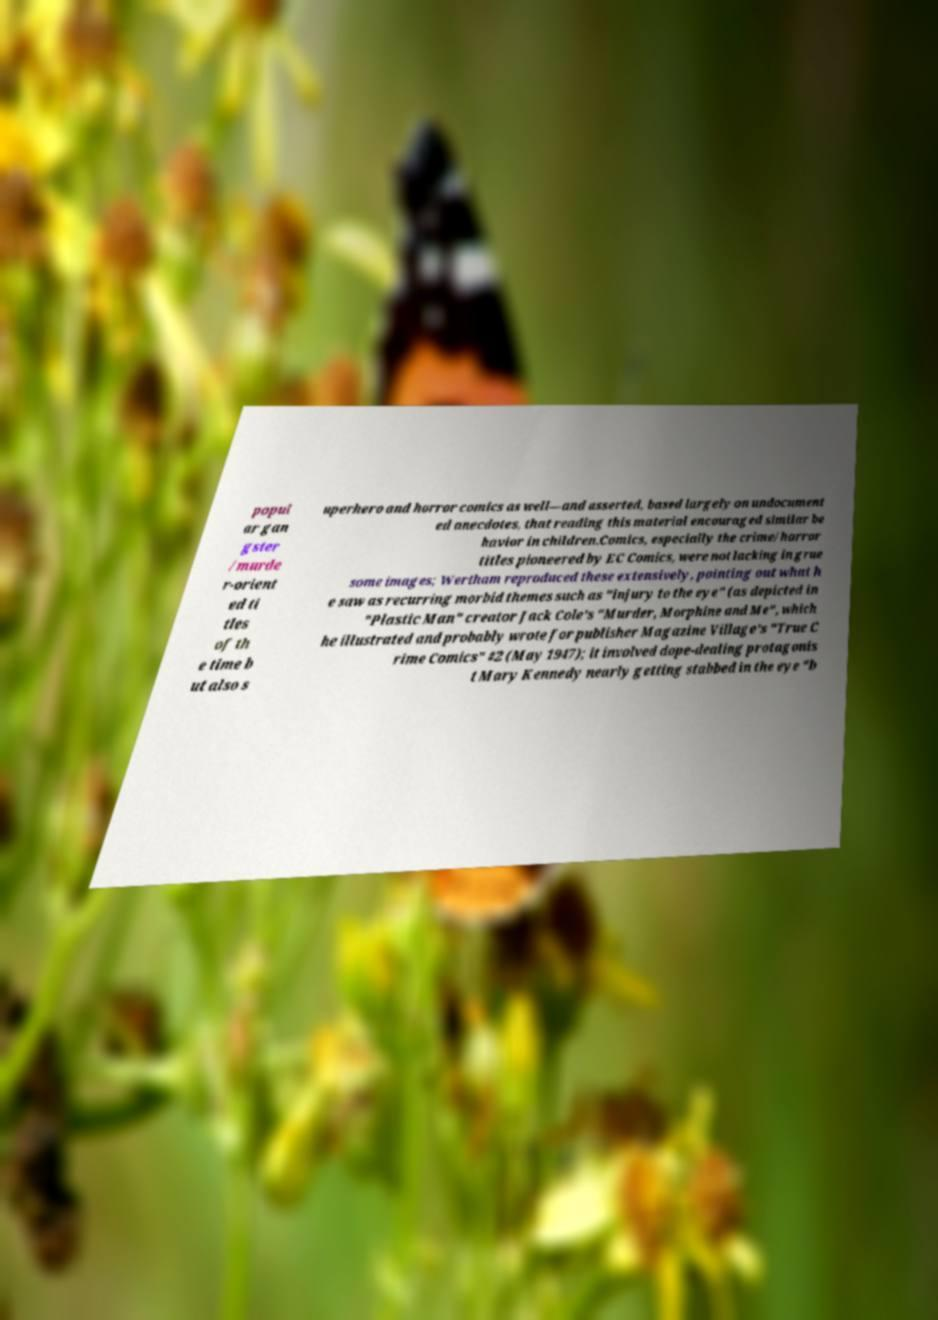I need the written content from this picture converted into text. Can you do that? popul ar gan gster /murde r-orient ed ti tles of th e time b ut also s uperhero and horror comics as well—and asserted, based largely on undocument ed anecdotes, that reading this material encouraged similar be havior in children.Comics, especially the crime/horror titles pioneered by EC Comics, were not lacking in grue some images; Wertham reproduced these extensively, pointing out what h e saw as recurring morbid themes such as "injury to the eye" (as depicted in "Plastic Man" creator Jack Cole's "Murder, Morphine and Me", which he illustrated and probably wrote for publisher Magazine Village's "True C rime Comics" #2 (May 1947); it involved dope-dealing protagonis t Mary Kennedy nearly getting stabbed in the eye "b 